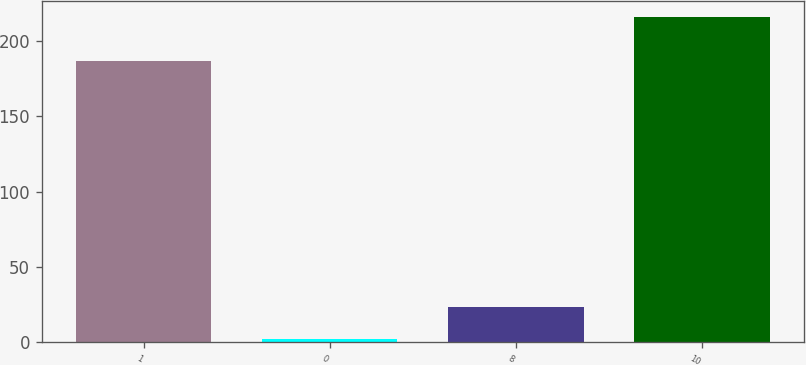Convert chart to OTSL. <chart><loc_0><loc_0><loc_500><loc_500><bar_chart><fcel>1<fcel>0<fcel>8<fcel>10<nl><fcel>187<fcel>2<fcel>23.4<fcel>216<nl></chart> 